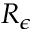Convert formula to latex. <formula><loc_0><loc_0><loc_500><loc_500>R _ { \epsilon }</formula> 